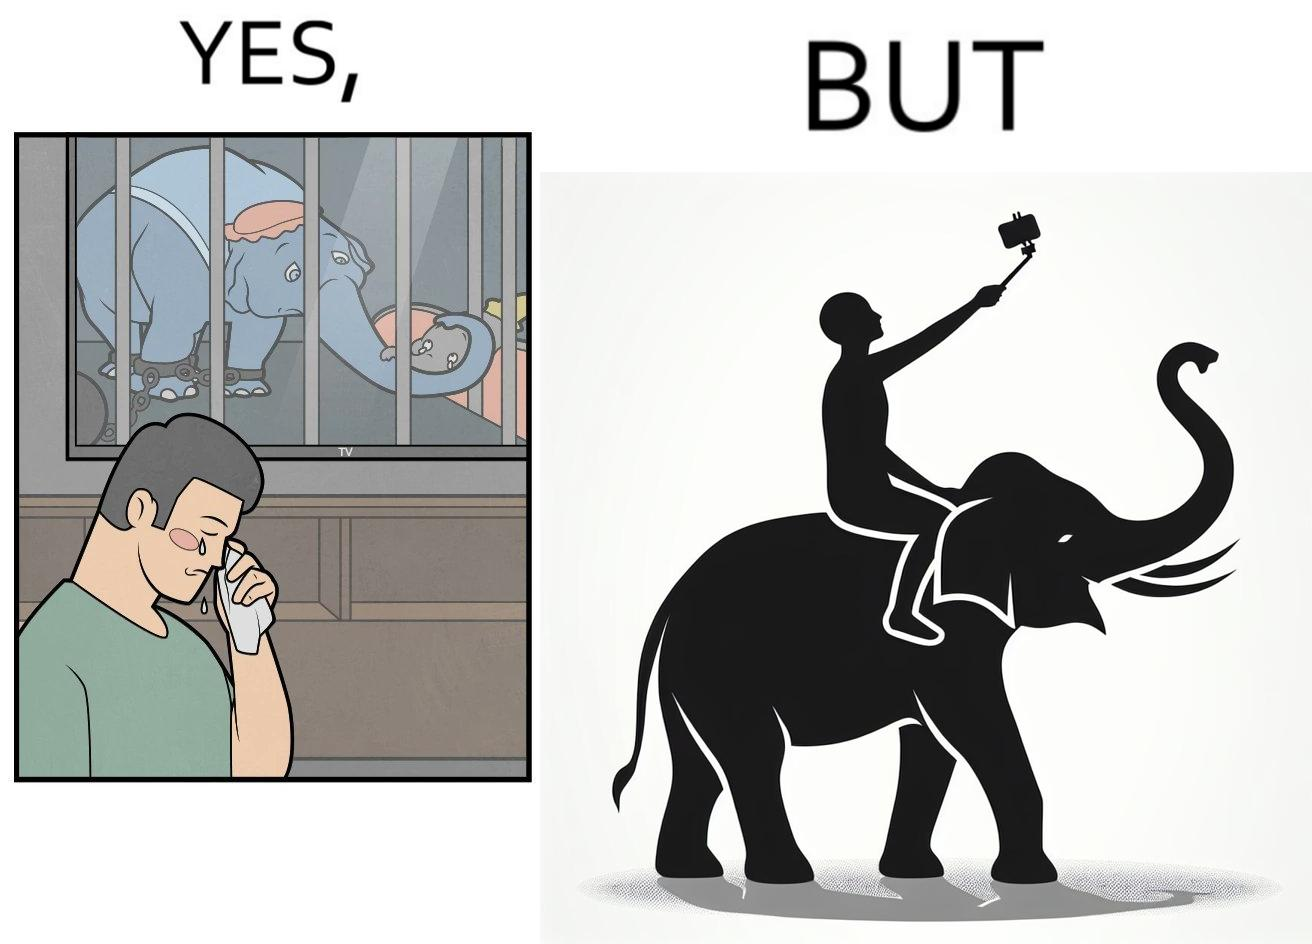Does this image contain satire or humor? Yes, this image is satirical. 